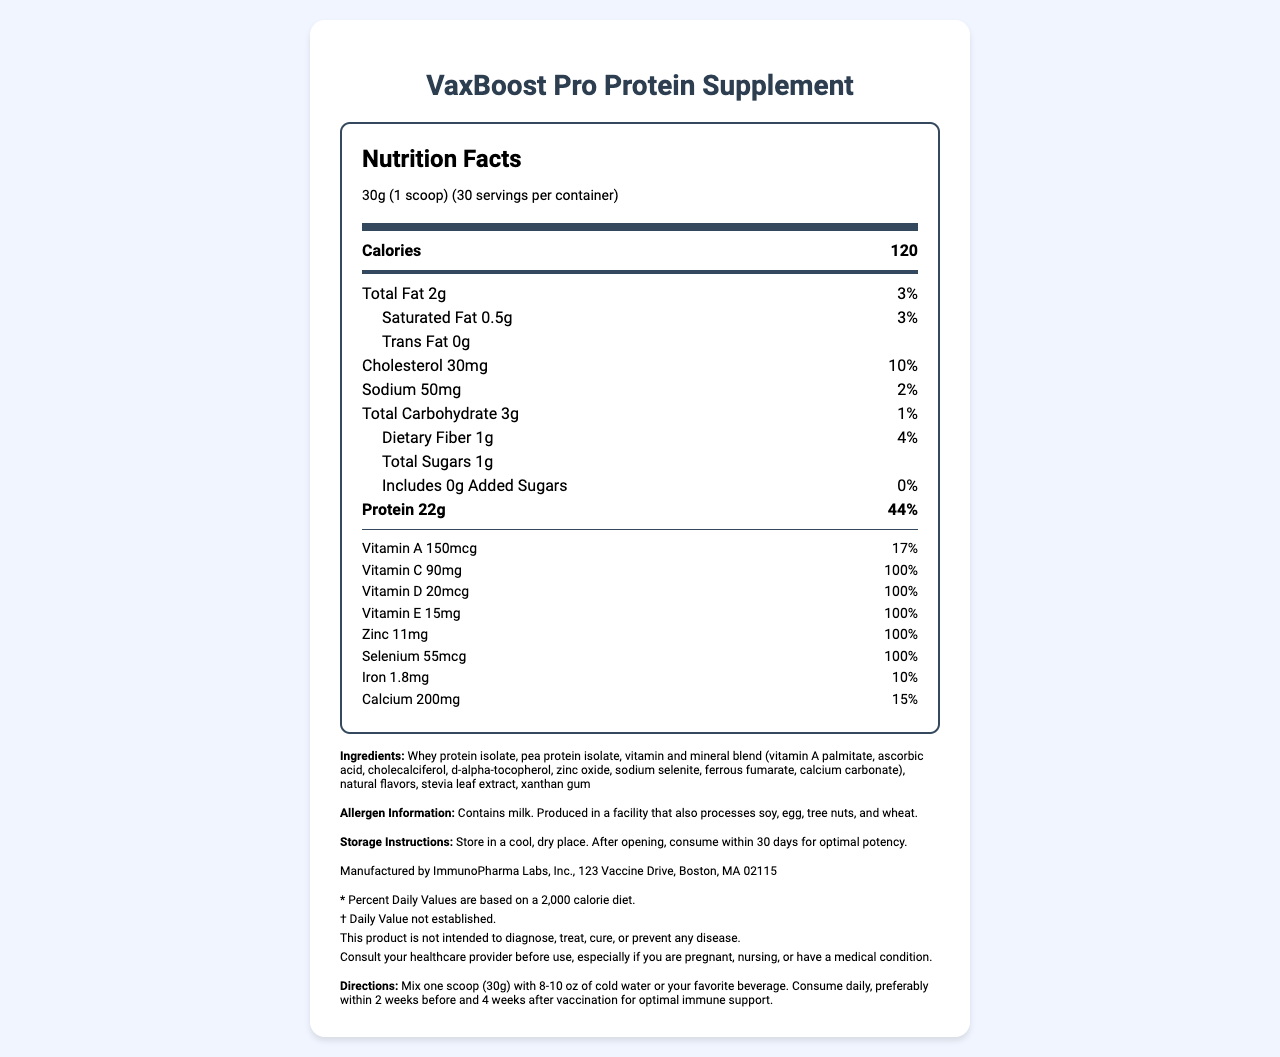What is the serving size? The serving size is specified in the first line under the heading "Nutrition Facts."
Answer: 30g (1 scoop) How many servings are in each container? The number of servings per container is directly mentioned under the serving size.
Answer: 30 What is the total amount of protein per serving? The amount of protein per serving is listed under the nutrition facts section for protein.
Answer: 22g What percentage of the daily value for Vitamin C does one serving provide? The percentage daily value for Vitamin C is listed in the nutrients section.
Answer: 100% How many calories are in one serving? The calorie content per serving is provided right after the serving information.
Answer: 120 calories Does this product contain any added sugars? The label mentions “Includes 0g Added Sugars” under the total sugars section.
Answer: No What is the sodium content per serving? The sodium content per serving is specified in the nutrition facts under the sodium section.
Answer: 50mg Who is the manufacturer of the VaxBoost Pro Protein Supplement? Manufacturer information is provided at the bottom of the document.
Answer: ImmunoPharma Labs, Inc. What are the main ingredients in this supplement? These ingredients are listed in the ingredients section of the document.
Answer: Whey protein isolate, pea protein isolate, vitamin and mineral blend, natural flavors, stevia leaf extract, xanthan gum Which of the following vitamins does VaxBoost Pro contain at 100% daily value? A. Vitamin A B. Vitamin C C. Vitamin D D. All of the above Vitamins A, C, D, E, Zinc, and Selenium are all listed with 100% daily value, covering choices B, C, and E.
Answer: D. All of the above Which ingredient listed is also an allergen? A. Pea protein isolate B. Whey protein isolate C. Xanthan gum D. Stevia leaf extract The allergen information section states that the product contains milk, which is derived from whey protein isolate.
Answer: B. Whey protein isolate Is there any iron in the VaxBoost Pro supplement? The nutrition facts section shows that iron is present with an amount of 1.8mg and a daily value percentage of 10%.
Answer: Yes Can the specific amount of Vitamin B12 be determined from this document? The document does not mention Vitamin B12 or its amount.
Answer: Not enough information Summarize the main idea of the document. The document presents the nutritional details and serves as guidance for using the VaxBoost Pro Protein Supplement as a means to support immune response in conjunction with vaccination, offering a comprehensive view of its components and benefits.
Answer: The VaxBoost Pro Protein Supplement provides detailed nutritional information, including serving size and nutrient content per serving. It lists ingredients, allergen information, and manufacturer details, along with conveying storage instructions and usage directions to enhance vaccine efficacy. Where should the product be stored? The storage instructions clearly state that the product should be stored in a cool, dry place and consumed within 30 days of opening for optimal potency.
Answer: In a cool, dry place 